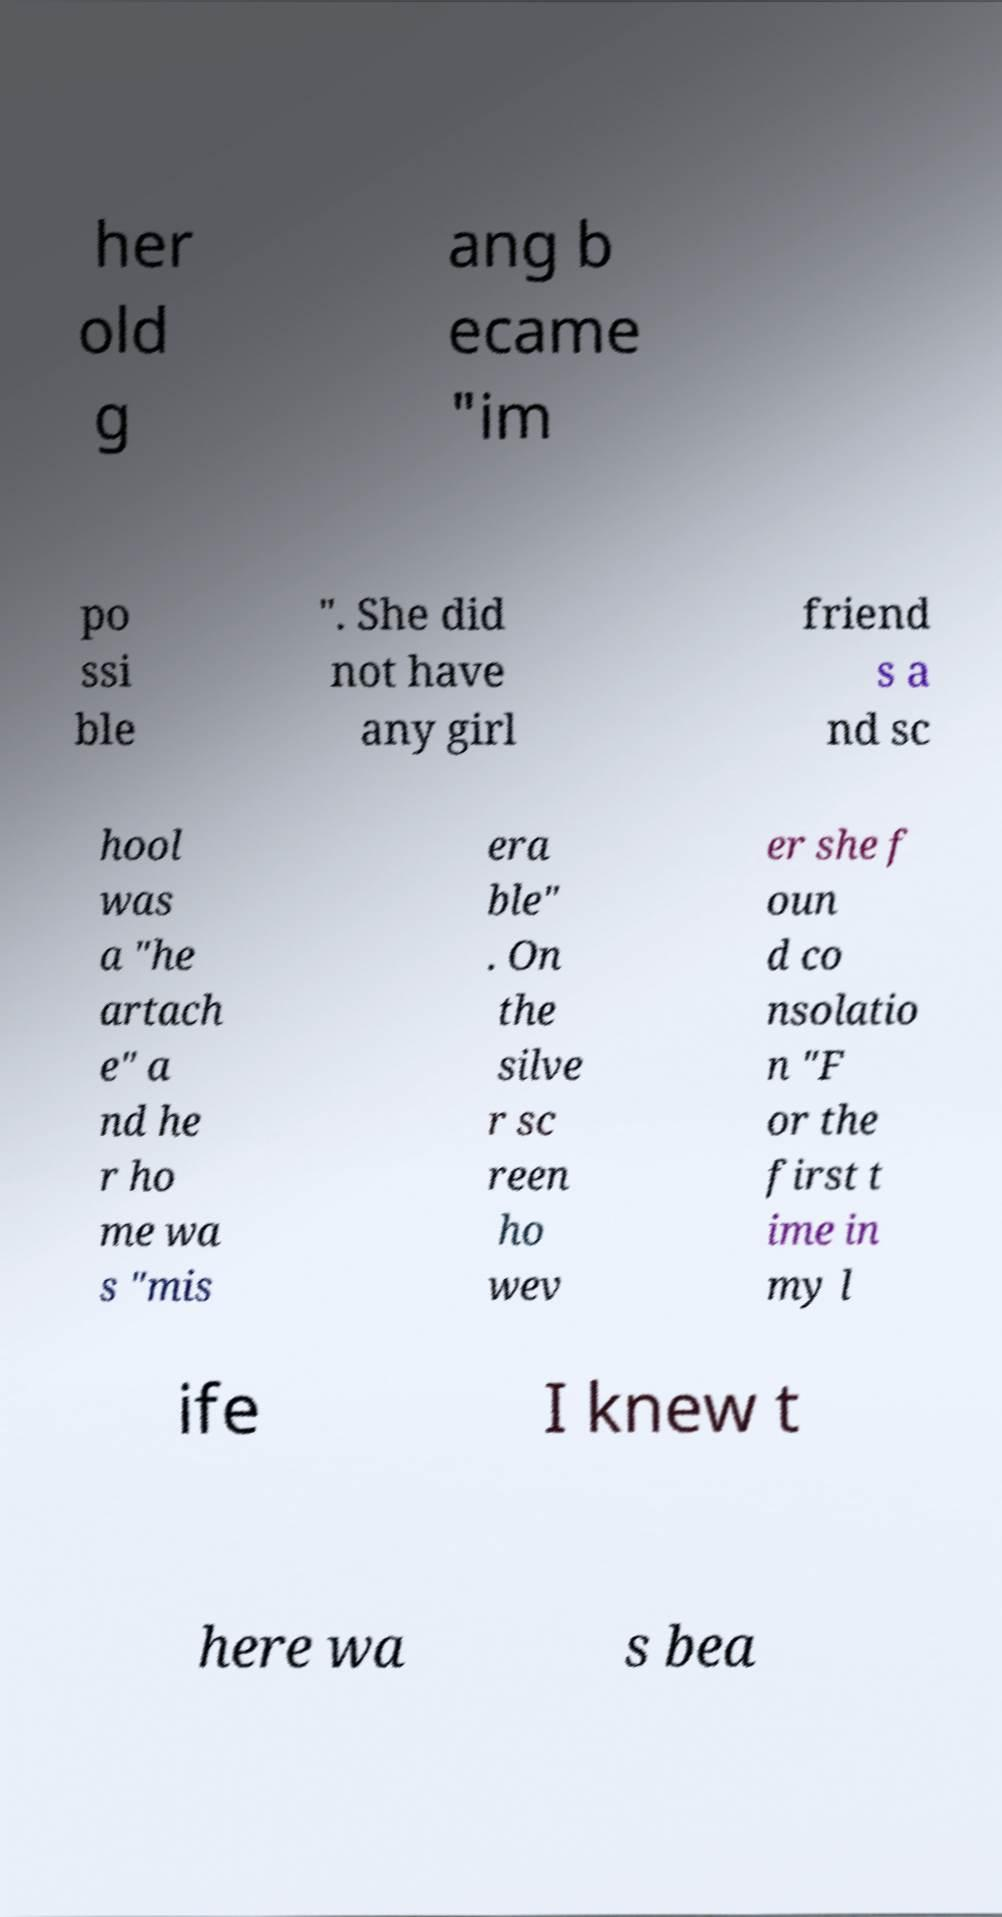Could you assist in decoding the text presented in this image and type it out clearly? her old g ang b ecame "im po ssi ble ". She did not have any girl friend s a nd sc hool was a "he artach e" a nd he r ho me wa s "mis era ble" . On the silve r sc reen ho wev er she f oun d co nsolatio n "F or the first t ime in my l ife I knew t here wa s bea 